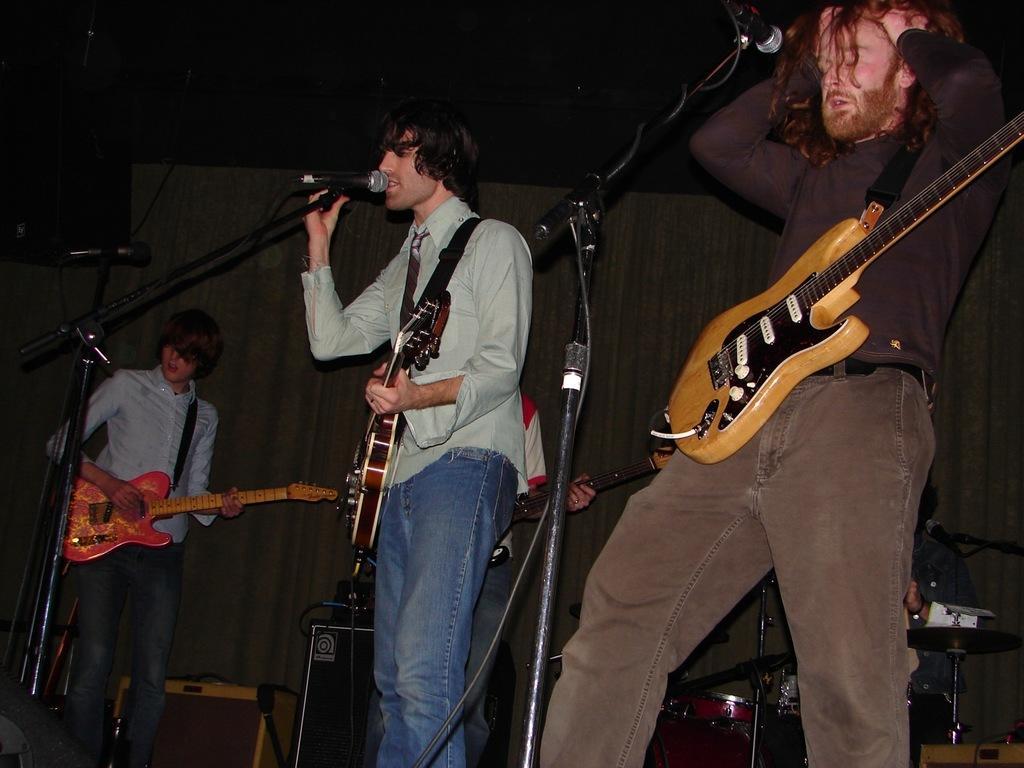How would you summarize this image in a sentence or two? In the center of the image we can see three persons are standing and they are holding guitars. In front of them, we can see microphones. In the background there is a wall, one person, table, speaker, musical instruments and a few other objects. 